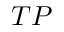<formula> <loc_0><loc_0><loc_500><loc_500>T P</formula> 